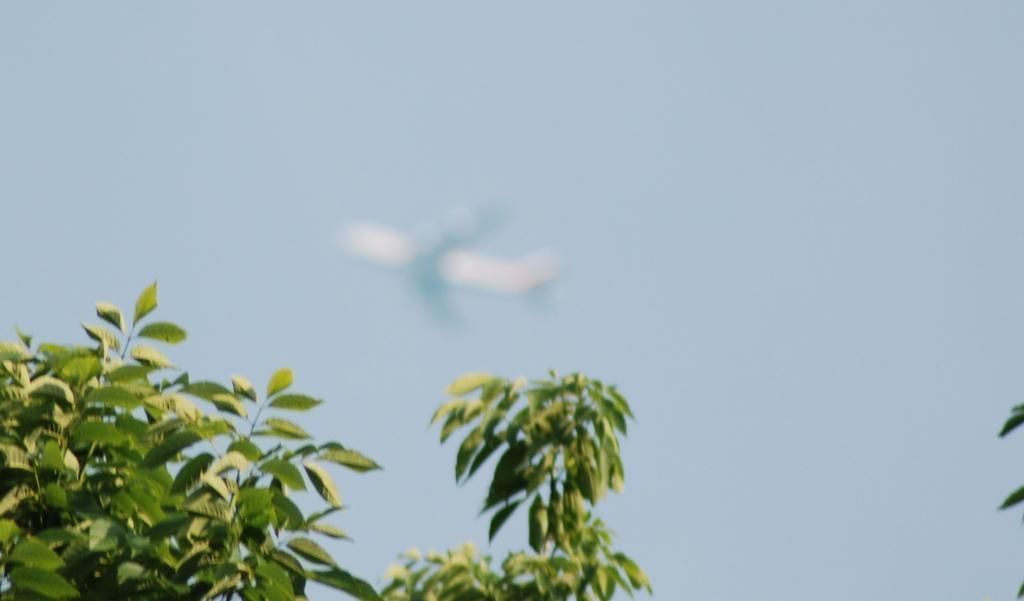Could you give a brief overview of what you see in this image? In this image we can see an airplane flying in the sky and some trees. 